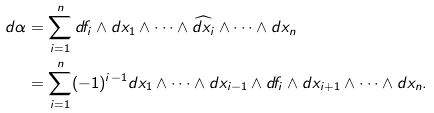<formula> <loc_0><loc_0><loc_500><loc_500>d \alpha & = \sum _ { i = 1 } ^ { n } d f _ { i } \wedge d x _ { 1 } \wedge \cdots \wedge \widehat { d x _ { i } } \wedge \cdots \wedge d x _ { n } \\ & = \sum _ { i = 1 } ^ { n } ( - 1 ) ^ { i - 1 } d x _ { 1 } \wedge \cdots \wedge d x _ { i - 1 } \wedge d f _ { i } \wedge d x _ { i + 1 } \wedge \cdots \wedge d x _ { n } .</formula> 